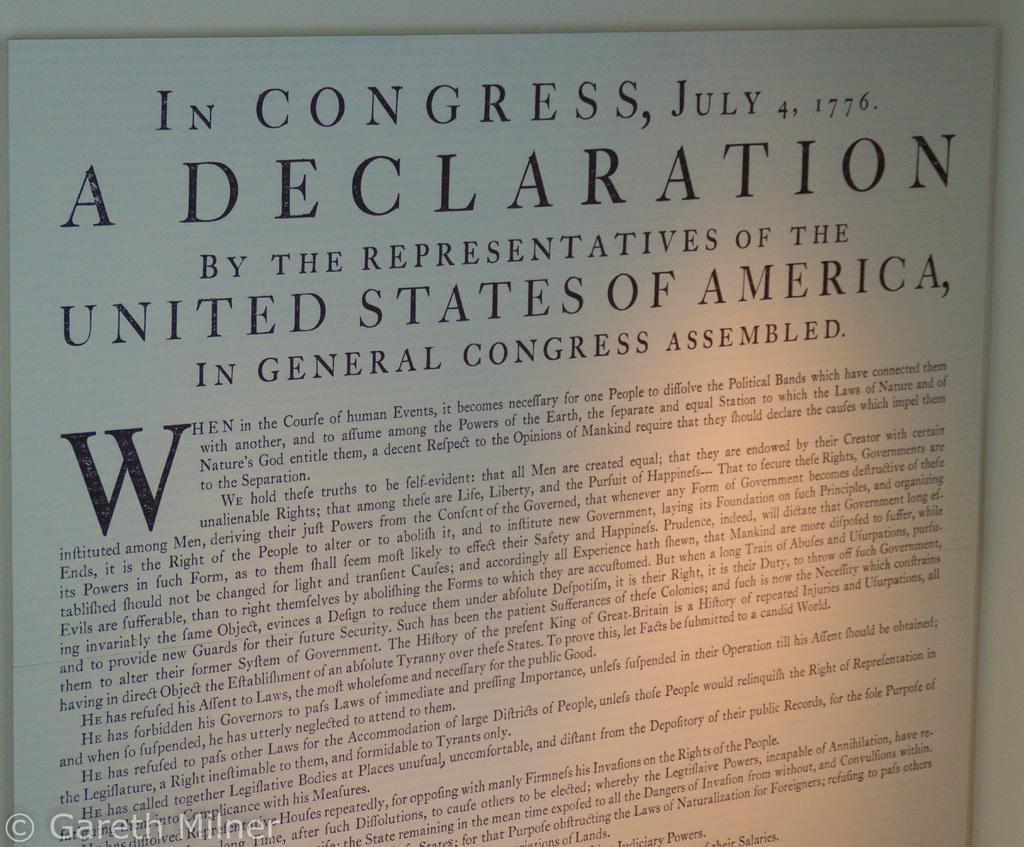<image>
Share a concise interpretation of the image provided. A copy of the declaration of independence from 1776 